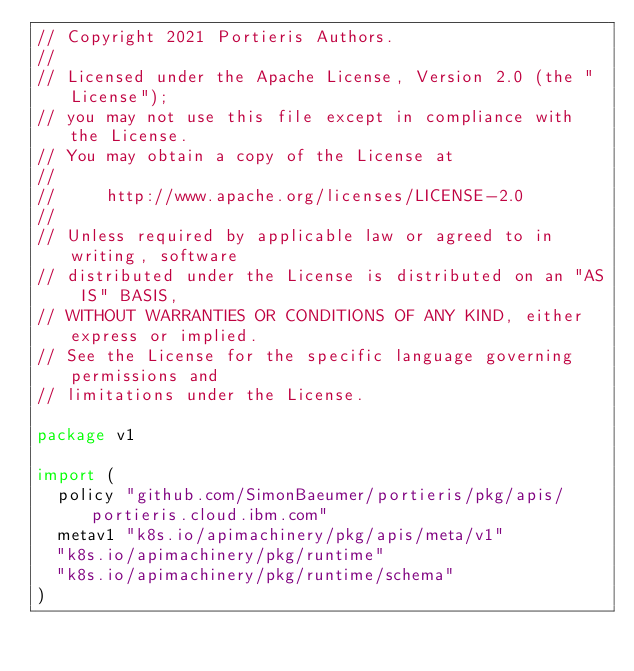Convert code to text. <code><loc_0><loc_0><loc_500><loc_500><_Go_>// Copyright 2021 Portieris Authors.
//
// Licensed under the Apache License, Version 2.0 (the "License");
// you may not use this file except in compliance with the License.
// You may obtain a copy of the License at
//
//     http://www.apache.org/licenses/LICENSE-2.0
//
// Unless required by applicable law or agreed to in writing, software
// distributed under the License is distributed on an "AS IS" BASIS,
// WITHOUT WARRANTIES OR CONDITIONS OF ANY KIND, either express or implied.
// See the License for the specific language governing permissions and
// limitations under the License.

package v1

import (
	policy "github.com/SimonBaeumer/portieris/pkg/apis/portieris.cloud.ibm.com"
	metav1 "k8s.io/apimachinery/pkg/apis/meta/v1"
	"k8s.io/apimachinery/pkg/runtime"
	"k8s.io/apimachinery/pkg/runtime/schema"
)
</code> 